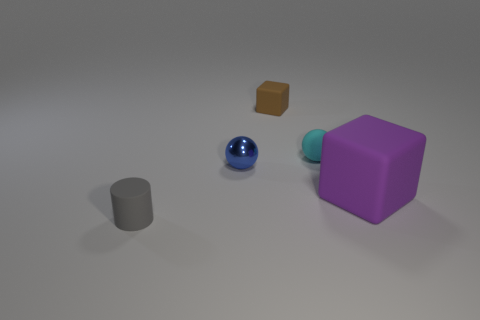Add 4 large brown rubber things. How many objects exist? 9 Subtract all cylinders. How many objects are left? 4 Add 2 small gray rubber objects. How many small gray rubber objects are left? 3 Add 5 large green metallic things. How many large green metallic things exist? 5 Subtract 0 gray blocks. How many objects are left? 5 Subtract all cyan objects. Subtract all gray matte things. How many objects are left? 3 